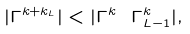<formula> <loc_0><loc_0><loc_500><loc_500>| \Gamma ^ { k + k _ { L } } | < | \Gamma ^ { k } \ \Gamma ^ { k } _ { L - 1 } | ,</formula> 